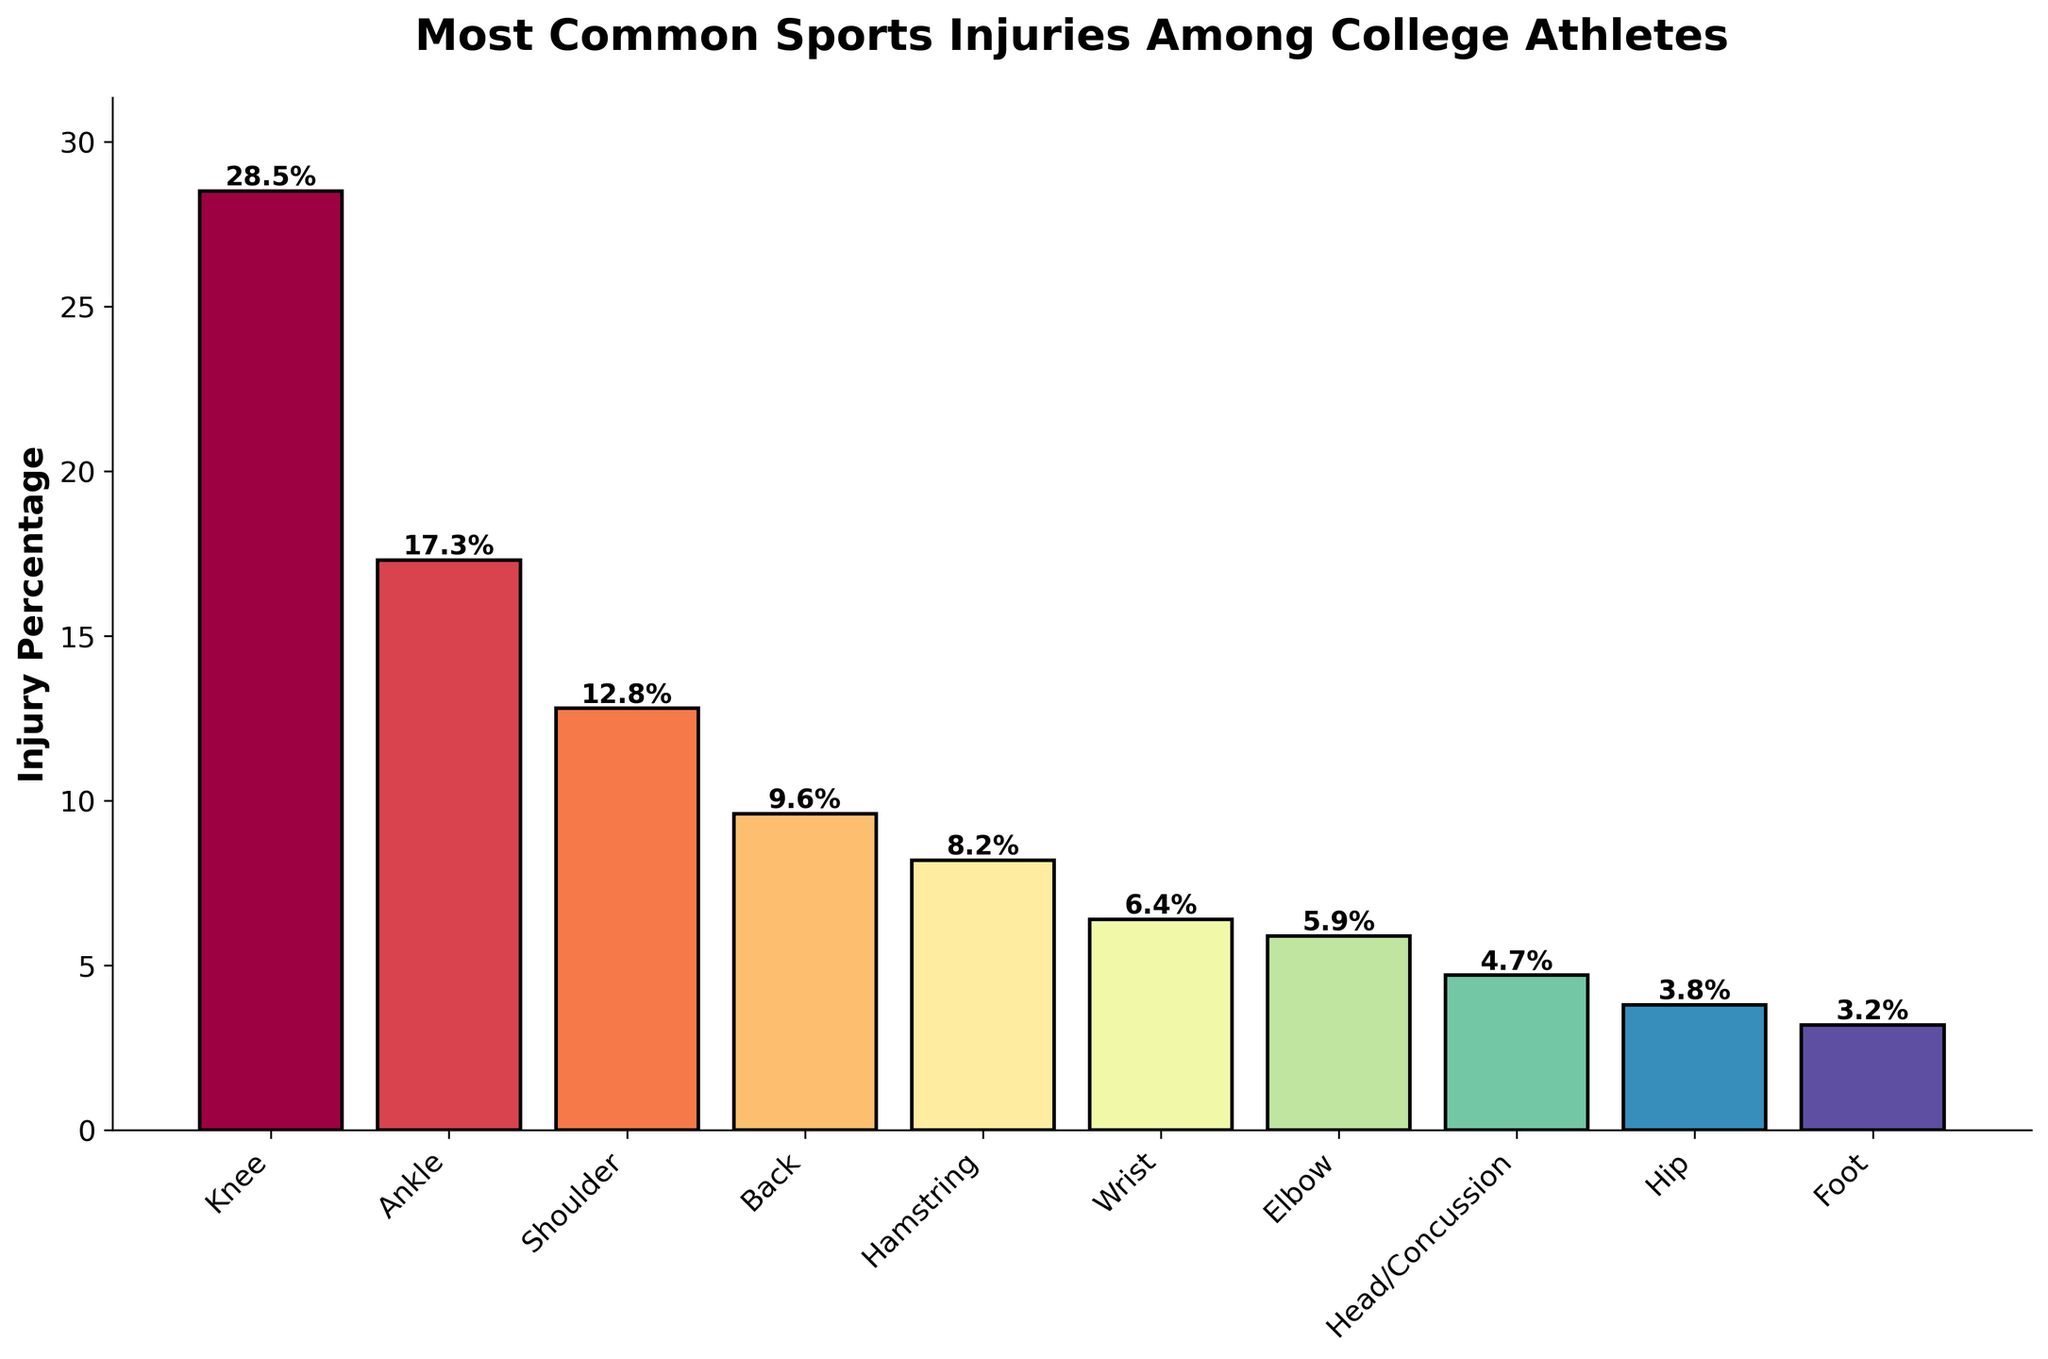Which body part has the highest injury percentage? The bar chart shows the percentage of injuries by body part. The tallest bar represents the body part with the highest injury percentage. In this case, the bar for the knee is the tallest at 28.5%.
Answer: Knee What is the total injury percentage for the top three most commonly injured body parts? To find the total percentage for the top three most commonly injured body parts, sum the percentages of Knee (28.5%), Ankle (17.3%), and Shoulder (12.8%). 28.5 + 17.3 + 12.8 = 58.6%
Answer: 58.6% Which body part has a lower injury percentage: Hamstring or Wrist? By comparing the heights of the bars representing the Hamstring (8.2%) and the Wrist (6.4%), we can see that the Wrist has a lower injury percentage.
Answer: Wrist How much greater is the injury percentage for the Knee compared to the Hip? To find the difference in injury percentages between the Knee (28.5%) and the Hip (3.8%), subtract the Hip percentage from the Knee percentage. 28.5 - 3.8 = 24.7%
Answer: 24.7% What is the average injury percentage for the Ankle, Shoulder, and Back? To find the average, sum the injury percentages for the Ankle (17.3%), Shoulder (12.8%), and Back (9.6%), then divide by 3. (17.3 + 12.8 + 9.6) / 3 = 39.7 / 3 = 13.23%
Answer: 13.23% Which body parts have an injury percentage less than 5%? The bars representing Head/Concussion (4.7%), Hip (3.8%), and Foot (3.2%) are the ones with injury percentages less than 5%.
Answer: Head/Concussion, Hip, and Foot How many body parts have an injury percentage above 10%? By examining the heights of the bars, we see that three body parts: Knee (28.5%), Ankle (17.3%), and Shoulder (12.8%) have injury percentages above 10%.
Answer: 3 What is the combined injury percentage of the back and elbow? To find the combined percentage, sum the injury percentages for the Back (9.6%) and Elbow (5.9%). 9.6 + 5.9 = 15.5%
Answer: 15.5% Between the Shoulder and Head/Concussion, which has a higher injury percentage and by how much? To find the difference, subtract the Head/Concussion percentage (4.7%) from the Shoulder percentage (12.8%). 12.8 - 4.7 = 8.1%. The Shoulder has a higher injury percentage by 8.1%.
Answer: Shoulder by 8.1% What percentage of injuries are attributed to the foot? The bar for the Foot indicates an injury percentage of 3.2%.
Answer: 3.2% 